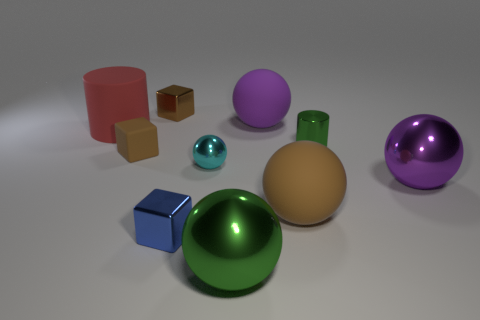There is a metal thing that is the same color as the tiny rubber thing; what size is it?
Give a very brief answer. Small. There is a big object that is right of the small brown matte thing and behind the small green thing; what material is it?
Give a very brief answer. Rubber. Is the small green metallic object the same shape as the large brown rubber thing?
Keep it short and to the point. No. Is there anything else that is the same size as the purple metallic ball?
Provide a succinct answer. Yes. What number of cylinders are right of the green shiny ball?
Your response must be concise. 1. Do the matte ball behind the red thing and the small shiny cylinder have the same size?
Your answer should be very brief. No. There is a big rubber object that is the same shape as the tiny green thing; what color is it?
Provide a short and direct response. Red. Are there any other things that are the same shape as the blue metallic object?
Keep it short and to the point. Yes. There is a large metallic thing that is to the left of the large brown object; what is its shape?
Provide a succinct answer. Sphere. What number of large rubber objects have the same shape as the tiny cyan thing?
Give a very brief answer. 2. 